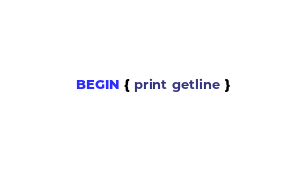Convert code to text. <code><loc_0><loc_0><loc_500><loc_500><_Awk_>BEGIN { print getline }</code> 